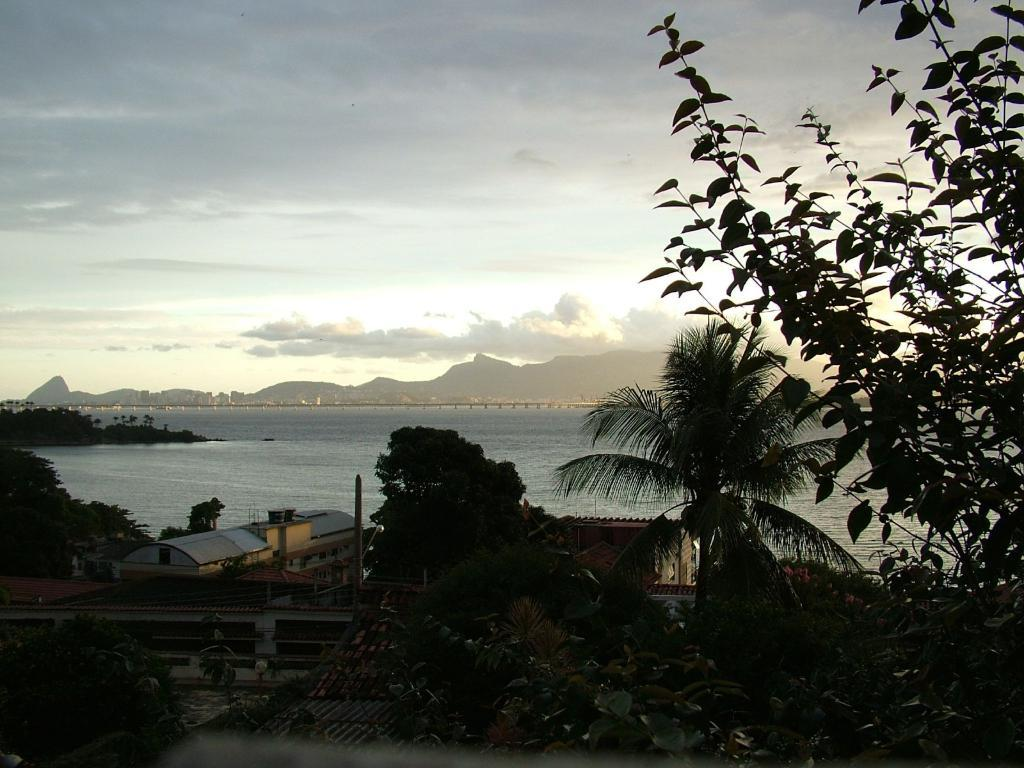What type of structures can be seen in the image? There are buildings in the image. What type of vegetation is present in the image? There are trees in the image. What natural feature can be seen in the background of the image? There is a river in the background of the image. What other geographical feature is visible in the background of the image? There are mountains in the background of the image. What part of the natural environment is visible in the background of the image? The sky is visible in the background of the image. What type of pollution can be seen in the image? There is no reference to pollution in the image; it features buildings, trees, a river, mountains, and the sky. Can you tell me how many tigers are visible in the image? There are no tigers present in the image. 